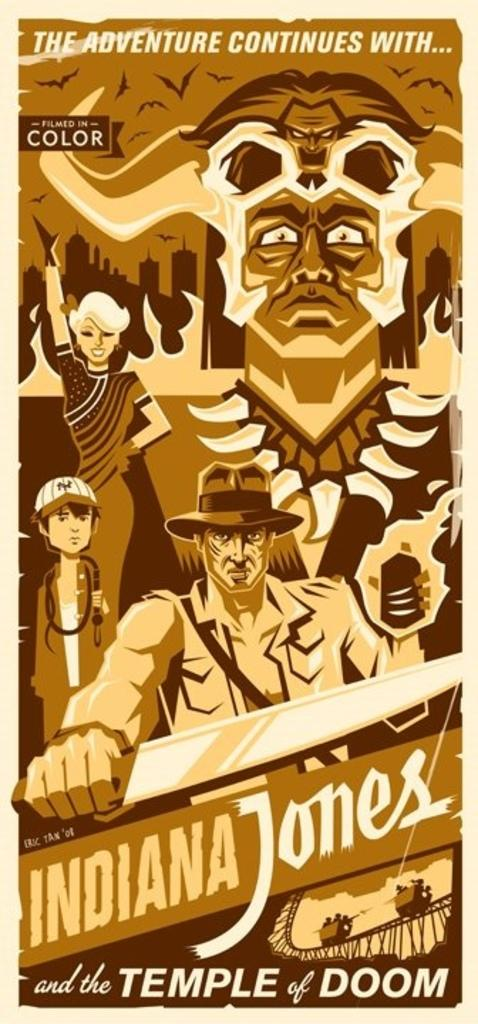<image>
Write a terse but informative summary of the picture. A cartoon depiction of the Indiana Jones and the Temple of Doom movie poster. 